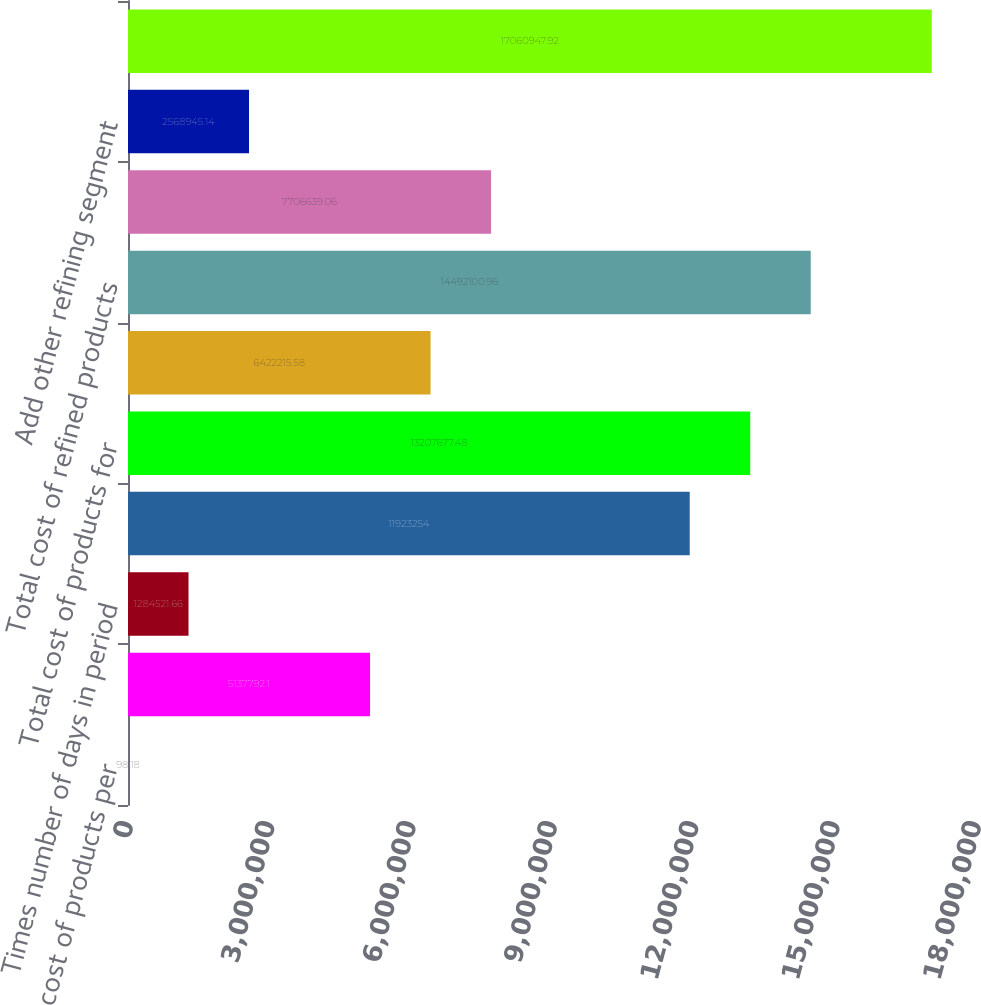Convert chart to OTSL. <chart><loc_0><loc_0><loc_500><loc_500><bar_chart><fcel>Average cost of products per<fcel>Times sales of produced<fcel>Times number of days in period<fcel>Cost of products for produced<fcel>Total cost of products for<fcel>Add refined product costs from<fcel>Total cost of refined products<fcel>Add crude oil cost of direct<fcel>Add other refining segment<fcel>Total refining segment cost of<nl><fcel>98.18<fcel>5.13779e+06<fcel>1.28452e+06<fcel>1.19233e+07<fcel>1.32077e+07<fcel>6.42222e+06<fcel>1.44921e+07<fcel>7.70664e+06<fcel>2.56895e+06<fcel>1.70609e+07<nl></chart> 